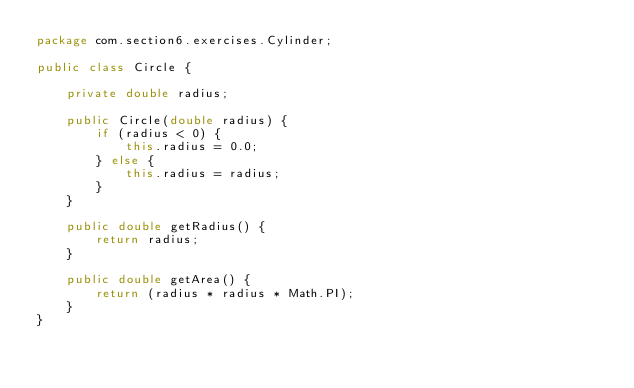<code> <loc_0><loc_0><loc_500><loc_500><_Java_>package com.section6.exercises.Cylinder;

public class Circle {

    private double radius;

    public Circle(double radius) {
        if (radius < 0) {
            this.radius = 0.0;
        } else {
            this.radius = radius;
        }
    }

    public double getRadius() {
        return radius;
    }

    public double getArea() {
        return (radius * radius * Math.PI);
    }
}
</code> 